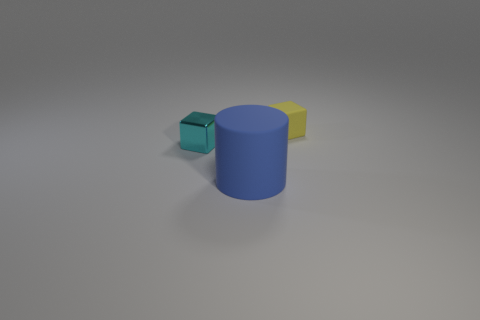Add 2 yellow matte cubes. How many objects exist? 5 Subtract all blocks. How many objects are left? 1 Subtract all small cyan blocks. Subtract all tiny red rubber cylinders. How many objects are left? 2 Add 1 blocks. How many blocks are left? 3 Add 1 yellow matte cubes. How many yellow matte cubes exist? 2 Subtract 1 yellow blocks. How many objects are left? 2 